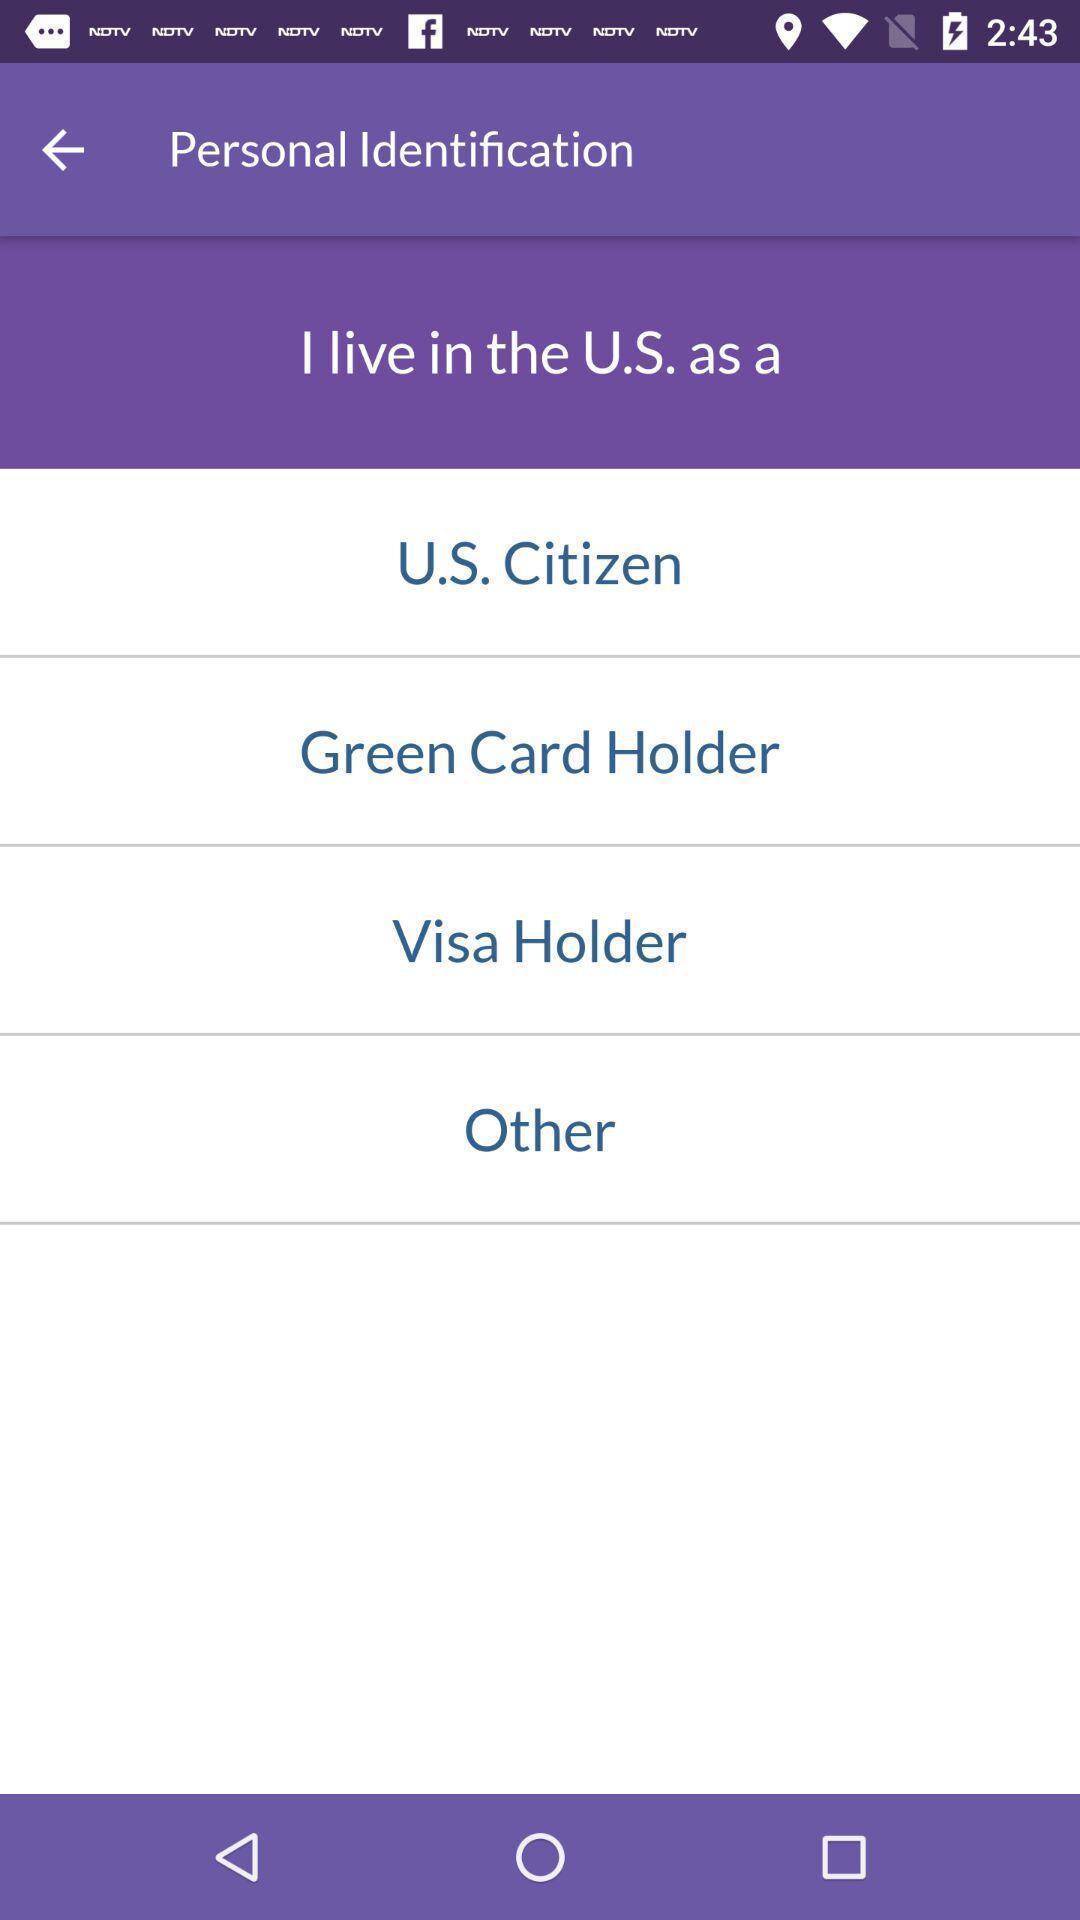What can you discern from this picture? Page displaying to select personal information in app. 